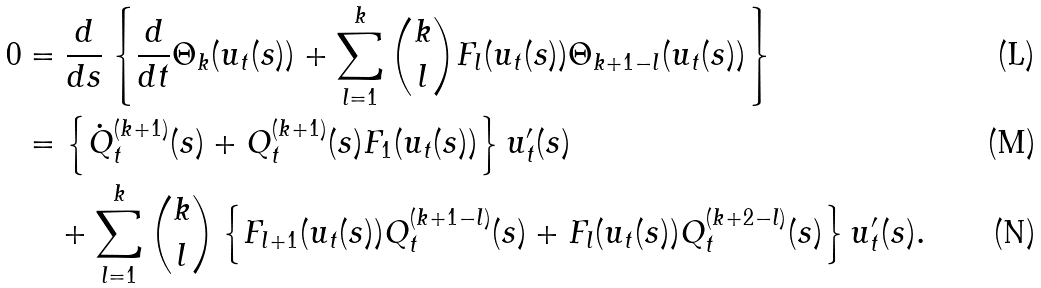<formula> <loc_0><loc_0><loc_500><loc_500>0 & = \frac { d } { d s } \left \{ \frac { d } { d t } \Theta _ { k } ( u _ { t } ( s ) ) + \sum _ { l = 1 } ^ { k } \binom { k } { l } F _ { l } ( u _ { t } ( s ) ) \Theta _ { k + 1 - l } ( u _ { t } ( s ) ) \right \} \\ & = \left \{ \dot { Q } _ { t } ^ { ( k + 1 ) } ( s ) + Q _ { t } ^ { ( k + 1 ) } ( s ) F _ { 1 } ( u _ { t } ( s ) ) \right \} u ^ { \prime } _ { t } ( s ) \\ & \quad + \sum _ { l = 1 } ^ { k } \binom { k } { l } \left \{ F _ { l + 1 } ( u _ { t } ( s ) ) Q _ { t } ^ { ( k + 1 - l ) } ( s ) + F _ { l } ( u _ { t } ( s ) ) Q _ { t } ^ { ( k + 2 - l ) } ( s ) \right \} u ^ { \prime } _ { t } ( s ) .</formula> 